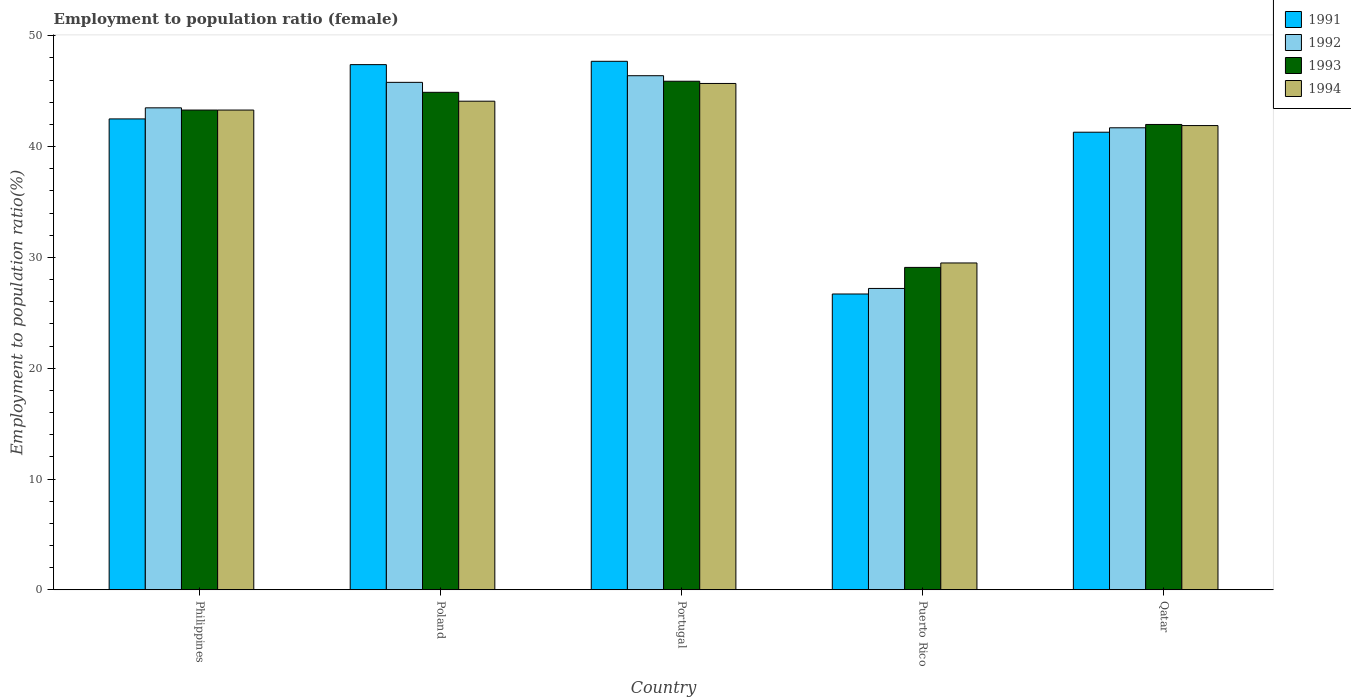How many different coloured bars are there?
Your answer should be compact. 4. How many bars are there on the 2nd tick from the left?
Offer a very short reply. 4. In how many cases, is the number of bars for a given country not equal to the number of legend labels?
Provide a succinct answer. 0. What is the employment to population ratio in 1991 in Philippines?
Provide a succinct answer. 42.5. Across all countries, what is the maximum employment to population ratio in 1991?
Offer a terse response. 47.7. Across all countries, what is the minimum employment to population ratio in 1992?
Offer a terse response. 27.2. In which country was the employment to population ratio in 1994 minimum?
Offer a terse response. Puerto Rico. What is the total employment to population ratio in 1992 in the graph?
Keep it short and to the point. 204.6. What is the difference between the employment to population ratio in 1991 in Poland and that in Portugal?
Give a very brief answer. -0.3. What is the difference between the employment to population ratio in 1994 in Portugal and the employment to population ratio in 1993 in Philippines?
Give a very brief answer. 2.4. What is the average employment to population ratio in 1992 per country?
Give a very brief answer. 40.92. What is the difference between the employment to population ratio of/in 1991 and employment to population ratio of/in 1993 in Philippines?
Ensure brevity in your answer.  -0.8. What is the ratio of the employment to population ratio in 1994 in Poland to that in Puerto Rico?
Offer a terse response. 1.49. Is the difference between the employment to population ratio in 1991 in Puerto Rico and Qatar greater than the difference between the employment to population ratio in 1993 in Puerto Rico and Qatar?
Give a very brief answer. No. What is the difference between the highest and the second highest employment to population ratio in 1991?
Provide a short and direct response. -4.9. What is the difference between the highest and the lowest employment to population ratio in 1991?
Offer a very short reply. 21. In how many countries, is the employment to population ratio in 1991 greater than the average employment to population ratio in 1991 taken over all countries?
Your answer should be very brief. 4. Is the sum of the employment to population ratio in 1992 in Philippines and Portugal greater than the maximum employment to population ratio in 1993 across all countries?
Make the answer very short. Yes. Is it the case that in every country, the sum of the employment to population ratio in 1993 and employment to population ratio in 1994 is greater than the sum of employment to population ratio in 1992 and employment to population ratio in 1991?
Ensure brevity in your answer.  No. What does the 2nd bar from the right in Qatar represents?
Offer a terse response. 1993. Is it the case that in every country, the sum of the employment to population ratio in 1994 and employment to population ratio in 1992 is greater than the employment to population ratio in 1993?
Keep it short and to the point. Yes. Are all the bars in the graph horizontal?
Your response must be concise. No. Does the graph contain any zero values?
Provide a short and direct response. No. Where does the legend appear in the graph?
Your answer should be compact. Top right. How are the legend labels stacked?
Ensure brevity in your answer.  Vertical. What is the title of the graph?
Your answer should be very brief. Employment to population ratio (female). Does "1968" appear as one of the legend labels in the graph?
Keep it short and to the point. No. What is the Employment to population ratio(%) of 1991 in Philippines?
Offer a terse response. 42.5. What is the Employment to population ratio(%) of 1992 in Philippines?
Offer a very short reply. 43.5. What is the Employment to population ratio(%) of 1993 in Philippines?
Give a very brief answer. 43.3. What is the Employment to population ratio(%) of 1994 in Philippines?
Provide a succinct answer. 43.3. What is the Employment to population ratio(%) in 1991 in Poland?
Provide a succinct answer. 47.4. What is the Employment to population ratio(%) of 1992 in Poland?
Keep it short and to the point. 45.8. What is the Employment to population ratio(%) in 1993 in Poland?
Your answer should be very brief. 44.9. What is the Employment to population ratio(%) in 1994 in Poland?
Make the answer very short. 44.1. What is the Employment to population ratio(%) of 1991 in Portugal?
Your response must be concise. 47.7. What is the Employment to population ratio(%) of 1992 in Portugal?
Offer a very short reply. 46.4. What is the Employment to population ratio(%) in 1993 in Portugal?
Keep it short and to the point. 45.9. What is the Employment to population ratio(%) in 1994 in Portugal?
Keep it short and to the point. 45.7. What is the Employment to population ratio(%) of 1991 in Puerto Rico?
Your answer should be compact. 26.7. What is the Employment to population ratio(%) of 1992 in Puerto Rico?
Your response must be concise. 27.2. What is the Employment to population ratio(%) in 1993 in Puerto Rico?
Make the answer very short. 29.1. What is the Employment to population ratio(%) of 1994 in Puerto Rico?
Provide a succinct answer. 29.5. What is the Employment to population ratio(%) of 1991 in Qatar?
Offer a terse response. 41.3. What is the Employment to population ratio(%) of 1992 in Qatar?
Offer a very short reply. 41.7. What is the Employment to population ratio(%) in 1994 in Qatar?
Your response must be concise. 41.9. Across all countries, what is the maximum Employment to population ratio(%) in 1991?
Offer a very short reply. 47.7. Across all countries, what is the maximum Employment to population ratio(%) in 1992?
Your response must be concise. 46.4. Across all countries, what is the maximum Employment to population ratio(%) in 1993?
Keep it short and to the point. 45.9. Across all countries, what is the maximum Employment to population ratio(%) in 1994?
Your answer should be very brief. 45.7. Across all countries, what is the minimum Employment to population ratio(%) of 1991?
Your answer should be compact. 26.7. Across all countries, what is the minimum Employment to population ratio(%) of 1992?
Provide a succinct answer. 27.2. Across all countries, what is the minimum Employment to population ratio(%) in 1993?
Your answer should be compact. 29.1. Across all countries, what is the minimum Employment to population ratio(%) of 1994?
Provide a short and direct response. 29.5. What is the total Employment to population ratio(%) of 1991 in the graph?
Offer a very short reply. 205.6. What is the total Employment to population ratio(%) of 1992 in the graph?
Offer a very short reply. 204.6. What is the total Employment to population ratio(%) of 1993 in the graph?
Provide a short and direct response. 205.2. What is the total Employment to population ratio(%) in 1994 in the graph?
Your answer should be compact. 204.5. What is the difference between the Employment to population ratio(%) of 1991 in Philippines and that in Poland?
Your response must be concise. -4.9. What is the difference between the Employment to population ratio(%) in 1993 in Philippines and that in Poland?
Offer a very short reply. -1.6. What is the difference between the Employment to population ratio(%) of 1994 in Philippines and that in Poland?
Make the answer very short. -0.8. What is the difference between the Employment to population ratio(%) in 1994 in Philippines and that in Portugal?
Give a very brief answer. -2.4. What is the difference between the Employment to population ratio(%) of 1993 in Philippines and that in Puerto Rico?
Keep it short and to the point. 14.2. What is the difference between the Employment to population ratio(%) of 1991 in Philippines and that in Qatar?
Your answer should be very brief. 1.2. What is the difference between the Employment to population ratio(%) in 1993 in Philippines and that in Qatar?
Offer a very short reply. 1.3. What is the difference between the Employment to population ratio(%) in 1993 in Poland and that in Portugal?
Your response must be concise. -1. What is the difference between the Employment to population ratio(%) of 1994 in Poland and that in Portugal?
Ensure brevity in your answer.  -1.6. What is the difference between the Employment to population ratio(%) of 1991 in Poland and that in Puerto Rico?
Make the answer very short. 20.7. What is the difference between the Employment to population ratio(%) of 1992 in Poland and that in Puerto Rico?
Provide a short and direct response. 18.6. What is the difference between the Employment to population ratio(%) of 1994 in Poland and that in Puerto Rico?
Offer a terse response. 14.6. What is the difference between the Employment to population ratio(%) in 1991 in Poland and that in Qatar?
Provide a short and direct response. 6.1. What is the difference between the Employment to population ratio(%) in 1992 in Poland and that in Qatar?
Ensure brevity in your answer.  4.1. What is the difference between the Employment to population ratio(%) in 1993 in Poland and that in Qatar?
Give a very brief answer. 2.9. What is the difference between the Employment to population ratio(%) of 1994 in Poland and that in Qatar?
Your response must be concise. 2.2. What is the difference between the Employment to population ratio(%) in 1992 in Portugal and that in Puerto Rico?
Give a very brief answer. 19.2. What is the difference between the Employment to population ratio(%) of 1993 in Portugal and that in Puerto Rico?
Provide a succinct answer. 16.8. What is the difference between the Employment to population ratio(%) of 1993 in Portugal and that in Qatar?
Ensure brevity in your answer.  3.9. What is the difference between the Employment to population ratio(%) of 1991 in Puerto Rico and that in Qatar?
Offer a terse response. -14.6. What is the difference between the Employment to population ratio(%) of 1992 in Puerto Rico and that in Qatar?
Your response must be concise. -14.5. What is the difference between the Employment to population ratio(%) in 1994 in Puerto Rico and that in Qatar?
Provide a succinct answer. -12.4. What is the difference between the Employment to population ratio(%) of 1991 in Philippines and the Employment to population ratio(%) of 1992 in Poland?
Your answer should be very brief. -3.3. What is the difference between the Employment to population ratio(%) of 1993 in Philippines and the Employment to population ratio(%) of 1994 in Poland?
Your answer should be compact. -0.8. What is the difference between the Employment to population ratio(%) of 1991 in Philippines and the Employment to population ratio(%) of 1993 in Portugal?
Offer a terse response. -3.4. What is the difference between the Employment to population ratio(%) of 1991 in Philippines and the Employment to population ratio(%) of 1994 in Portugal?
Make the answer very short. -3.2. What is the difference between the Employment to population ratio(%) of 1992 in Philippines and the Employment to population ratio(%) of 1993 in Portugal?
Make the answer very short. -2.4. What is the difference between the Employment to population ratio(%) in 1993 in Philippines and the Employment to population ratio(%) in 1994 in Portugal?
Ensure brevity in your answer.  -2.4. What is the difference between the Employment to population ratio(%) in 1991 in Philippines and the Employment to population ratio(%) in 1992 in Puerto Rico?
Ensure brevity in your answer.  15.3. What is the difference between the Employment to population ratio(%) in 1991 in Philippines and the Employment to population ratio(%) in 1993 in Puerto Rico?
Provide a short and direct response. 13.4. What is the difference between the Employment to population ratio(%) in 1991 in Philippines and the Employment to population ratio(%) in 1994 in Puerto Rico?
Your answer should be compact. 13. What is the difference between the Employment to population ratio(%) of 1991 in Philippines and the Employment to population ratio(%) of 1992 in Qatar?
Make the answer very short. 0.8. What is the difference between the Employment to population ratio(%) of 1991 in Philippines and the Employment to population ratio(%) of 1993 in Qatar?
Give a very brief answer. 0.5. What is the difference between the Employment to population ratio(%) in 1993 in Philippines and the Employment to population ratio(%) in 1994 in Qatar?
Keep it short and to the point. 1.4. What is the difference between the Employment to population ratio(%) in 1991 in Poland and the Employment to population ratio(%) in 1992 in Portugal?
Keep it short and to the point. 1. What is the difference between the Employment to population ratio(%) of 1992 in Poland and the Employment to population ratio(%) of 1993 in Portugal?
Offer a very short reply. -0.1. What is the difference between the Employment to population ratio(%) of 1993 in Poland and the Employment to population ratio(%) of 1994 in Portugal?
Provide a short and direct response. -0.8. What is the difference between the Employment to population ratio(%) in 1991 in Poland and the Employment to population ratio(%) in 1992 in Puerto Rico?
Your answer should be compact. 20.2. What is the difference between the Employment to population ratio(%) in 1991 in Poland and the Employment to population ratio(%) in 1993 in Puerto Rico?
Your answer should be compact. 18.3. What is the difference between the Employment to population ratio(%) of 1991 in Poland and the Employment to population ratio(%) of 1994 in Puerto Rico?
Ensure brevity in your answer.  17.9. What is the difference between the Employment to population ratio(%) in 1992 in Poland and the Employment to population ratio(%) in 1993 in Puerto Rico?
Your answer should be very brief. 16.7. What is the difference between the Employment to population ratio(%) of 1992 in Poland and the Employment to population ratio(%) of 1994 in Puerto Rico?
Your answer should be compact. 16.3. What is the difference between the Employment to population ratio(%) of 1993 in Poland and the Employment to population ratio(%) of 1994 in Puerto Rico?
Offer a very short reply. 15.4. What is the difference between the Employment to population ratio(%) of 1991 in Poland and the Employment to population ratio(%) of 1992 in Qatar?
Ensure brevity in your answer.  5.7. What is the difference between the Employment to population ratio(%) in 1991 in Portugal and the Employment to population ratio(%) in 1992 in Puerto Rico?
Keep it short and to the point. 20.5. What is the difference between the Employment to population ratio(%) in 1991 in Portugal and the Employment to population ratio(%) in 1993 in Puerto Rico?
Your answer should be compact. 18.6. What is the difference between the Employment to population ratio(%) of 1993 in Portugal and the Employment to population ratio(%) of 1994 in Puerto Rico?
Provide a succinct answer. 16.4. What is the difference between the Employment to population ratio(%) in 1991 in Portugal and the Employment to population ratio(%) in 1992 in Qatar?
Make the answer very short. 6. What is the difference between the Employment to population ratio(%) of 1992 in Portugal and the Employment to population ratio(%) of 1993 in Qatar?
Offer a very short reply. 4.4. What is the difference between the Employment to population ratio(%) in 1993 in Portugal and the Employment to population ratio(%) in 1994 in Qatar?
Keep it short and to the point. 4. What is the difference between the Employment to population ratio(%) of 1991 in Puerto Rico and the Employment to population ratio(%) of 1993 in Qatar?
Your answer should be compact. -15.3. What is the difference between the Employment to population ratio(%) in 1991 in Puerto Rico and the Employment to population ratio(%) in 1994 in Qatar?
Your answer should be very brief. -15.2. What is the difference between the Employment to population ratio(%) of 1992 in Puerto Rico and the Employment to population ratio(%) of 1993 in Qatar?
Offer a very short reply. -14.8. What is the difference between the Employment to population ratio(%) of 1992 in Puerto Rico and the Employment to population ratio(%) of 1994 in Qatar?
Your response must be concise. -14.7. What is the difference between the Employment to population ratio(%) of 1993 in Puerto Rico and the Employment to population ratio(%) of 1994 in Qatar?
Your response must be concise. -12.8. What is the average Employment to population ratio(%) of 1991 per country?
Keep it short and to the point. 41.12. What is the average Employment to population ratio(%) in 1992 per country?
Your answer should be very brief. 40.92. What is the average Employment to population ratio(%) in 1993 per country?
Make the answer very short. 41.04. What is the average Employment to population ratio(%) of 1994 per country?
Keep it short and to the point. 40.9. What is the difference between the Employment to population ratio(%) of 1992 and Employment to population ratio(%) of 1994 in Philippines?
Keep it short and to the point. 0.2. What is the difference between the Employment to population ratio(%) in 1991 and Employment to population ratio(%) in 1992 in Poland?
Your response must be concise. 1.6. What is the difference between the Employment to population ratio(%) of 1992 and Employment to population ratio(%) of 1993 in Poland?
Give a very brief answer. 0.9. What is the difference between the Employment to population ratio(%) in 1992 and Employment to population ratio(%) in 1994 in Poland?
Provide a short and direct response. 1.7. What is the difference between the Employment to population ratio(%) of 1993 and Employment to population ratio(%) of 1994 in Poland?
Keep it short and to the point. 0.8. What is the difference between the Employment to population ratio(%) of 1991 and Employment to population ratio(%) of 1994 in Portugal?
Offer a very short reply. 2. What is the difference between the Employment to population ratio(%) in 1992 and Employment to population ratio(%) in 1993 in Portugal?
Offer a terse response. 0.5. What is the difference between the Employment to population ratio(%) of 1992 and Employment to population ratio(%) of 1994 in Portugal?
Give a very brief answer. 0.7. What is the difference between the Employment to population ratio(%) of 1991 and Employment to population ratio(%) of 1994 in Puerto Rico?
Make the answer very short. -2.8. What is the difference between the Employment to population ratio(%) of 1992 and Employment to population ratio(%) of 1993 in Puerto Rico?
Ensure brevity in your answer.  -1.9. What is the difference between the Employment to population ratio(%) in 1992 and Employment to population ratio(%) in 1994 in Puerto Rico?
Keep it short and to the point. -2.3. What is the difference between the Employment to population ratio(%) in 1991 and Employment to population ratio(%) in 1992 in Qatar?
Offer a very short reply. -0.4. What is the difference between the Employment to population ratio(%) of 1992 and Employment to population ratio(%) of 1993 in Qatar?
Your response must be concise. -0.3. What is the difference between the Employment to population ratio(%) of 1993 and Employment to population ratio(%) of 1994 in Qatar?
Keep it short and to the point. 0.1. What is the ratio of the Employment to population ratio(%) of 1991 in Philippines to that in Poland?
Ensure brevity in your answer.  0.9. What is the ratio of the Employment to population ratio(%) in 1992 in Philippines to that in Poland?
Offer a terse response. 0.95. What is the ratio of the Employment to population ratio(%) of 1993 in Philippines to that in Poland?
Ensure brevity in your answer.  0.96. What is the ratio of the Employment to population ratio(%) in 1994 in Philippines to that in Poland?
Your answer should be very brief. 0.98. What is the ratio of the Employment to population ratio(%) in 1991 in Philippines to that in Portugal?
Your answer should be very brief. 0.89. What is the ratio of the Employment to population ratio(%) of 1992 in Philippines to that in Portugal?
Make the answer very short. 0.94. What is the ratio of the Employment to population ratio(%) in 1993 in Philippines to that in Portugal?
Provide a succinct answer. 0.94. What is the ratio of the Employment to population ratio(%) in 1994 in Philippines to that in Portugal?
Ensure brevity in your answer.  0.95. What is the ratio of the Employment to population ratio(%) in 1991 in Philippines to that in Puerto Rico?
Provide a succinct answer. 1.59. What is the ratio of the Employment to population ratio(%) in 1992 in Philippines to that in Puerto Rico?
Your answer should be compact. 1.6. What is the ratio of the Employment to population ratio(%) of 1993 in Philippines to that in Puerto Rico?
Make the answer very short. 1.49. What is the ratio of the Employment to population ratio(%) of 1994 in Philippines to that in Puerto Rico?
Offer a very short reply. 1.47. What is the ratio of the Employment to population ratio(%) of 1991 in Philippines to that in Qatar?
Offer a terse response. 1.03. What is the ratio of the Employment to population ratio(%) of 1992 in Philippines to that in Qatar?
Offer a very short reply. 1.04. What is the ratio of the Employment to population ratio(%) in 1993 in Philippines to that in Qatar?
Provide a short and direct response. 1.03. What is the ratio of the Employment to population ratio(%) in 1994 in Philippines to that in Qatar?
Provide a short and direct response. 1.03. What is the ratio of the Employment to population ratio(%) in 1991 in Poland to that in Portugal?
Ensure brevity in your answer.  0.99. What is the ratio of the Employment to population ratio(%) of 1992 in Poland to that in Portugal?
Your answer should be compact. 0.99. What is the ratio of the Employment to population ratio(%) in 1993 in Poland to that in Portugal?
Your answer should be compact. 0.98. What is the ratio of the Employment to population ratio(%) of 1994 in Poland to that in Portugal?
Provide a short and direct response. 0.96. What is the ratio of the Employment to population ratio(%) of 1991 in Poland to that in Puerto Rico?
Your answer should be very brief. 1.78. What is the ratio of the Employment to population ratio(%) of 1992 in Poland to that in Puerto Rico?
Your answer should be compact. 1.68. What is the ratio of the Employment to population ratio(%) of 1993 in Poland to that in Puerto Rico?
Your response must be concise. 1.54. What is the ratio of the Employment to population ratio(%) of 1994 in Poland to that in Puerto Rico?
Ensure brevity in your answer.  1.49. What is the ratio of the Employment to population ratio(%) of 1991 in Poland to that in Qatar?
Keep it short and to the point. 1.15. What is the ratio of the Employment to population ratio(%) in 1992 in Poland to that in Qatar?
Your answer should be very brief. 1.1. What is the ratio of the Employment to population ratio(%) in 1993 in Poland to that in Qatar?
Provide a succinct answer. 1.07. What is the ratio of the Employment to population ratio(%) in 1994 in Poland to that in Qatar?
Provide a short and direct response. 1.05. What is the ratio of the Employment to population ratio(%) of 1991 in Portugal to that in Puerto Rico?
Offer a terse response. 1.79. What is the ratio of the Employment to population ratio(%) in 1992 in Portugal to that in Puerto Rico?
Offer a very short reply. 1.71. What is the ratio of the Employment to population ratio(%) of 1993 in Portugal to that in Puerto Rico?
Your response must be concise. 1.58. What is the ratio of the Employment to population ratio(%) in 1994 in Portugal to that in Puerto Rico?
Your answer should be very brief. 1.55. What is the ratio of the Employment to population ratio(%) in 1991 in Portugal to that in Qatar?
Provide a succinct answer. 1.16. What is the ratio of the Employment to population ratio(%) in 1992 in Portugal to that in Qatar?
Offer a terse response. 1.11. What is the ratio of the Employment to population ratio(%) of 1993 in Portugal to that in Qatar?
Provide a succinct answer. 1.09. What is the ratio of the Employment to population ratio(%) of 1994 in Portugal to that in Qatar?
Your response must be concise. 1.09. What is the ratio of the Employment to population ratio(%) of 1991 in Puerto Rico to that in Qatar?
Offer a very short reply. 0.65. What is the ratio of the Employment to population ratio(%) of 1992 in Puerto Rico to that in Qatar?
Give a very brief answer. 0.65. What is the ratio of the Employment to population ratio(%) in 1993 in Puerto Rico to that in Qatar?
Ensure brevity in your answer.  0.69. What is the ratio of the Employment to population ratio(%) of 1994 in Puerto Rico to that in Qatar?
Make the answer very short. 0.7. What is the difference between the highest and the second highest Employment to population ratio(%) of 1993?
Provide a short and direct response. 1. What is the difference between the highest and the lowest Employment to population ratio(%) of 1991?
Provide a short and direct response. 21. What is the difference between the highest and the lowest Employment to population ratio(%) in 1992?
Offer a terse response. 19.2. What is the difference between the highest and the lowest Employment to population ratio(%) in 1993?
Provide a succinct answer. 16.8. What is the difference between the highest and the lowest Employment to population ratio(%) in 1994?
Offer a very short reply. 16.2. 